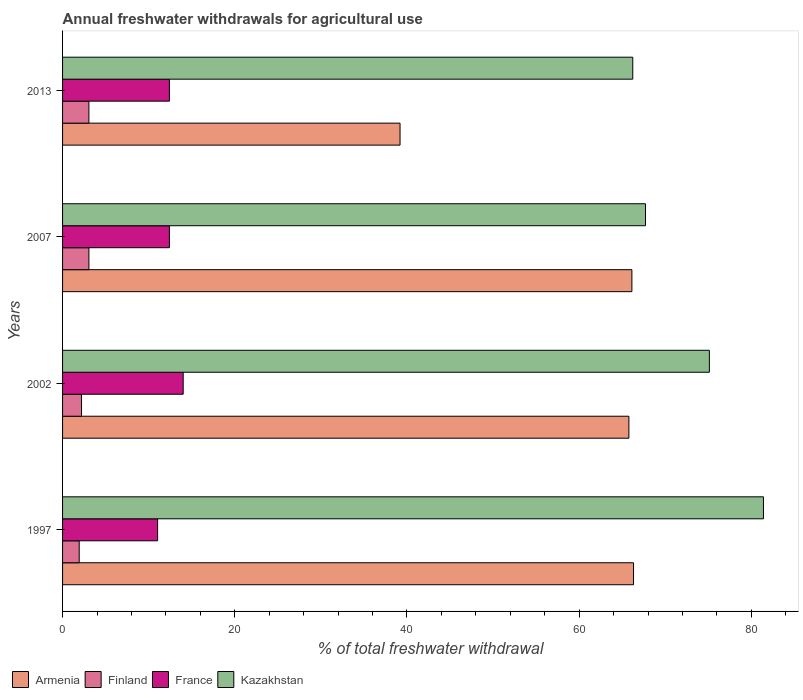How many different coloured bars are there?
Your answer should be very brief. 4. How many groups of bars are there?
Offer a terse response. 4. Are the number of bars per tick equal to the number of legend labels?
Provide a succinct answer. Yes. How many bars are there on the 3rd tick from the top?
Provide a succinct answer. 4. How many bars are there on the 1st tick from the bottom?
Provide a short and direct response. 4. What is the label of the 4th group of bars from the top?
Offer a terse response. 1997. What is the total annual withdrawals from freshwater in Finland in 2007?
Your answer should be compact. 3.06. Across all years, what is the maximum total annual withdrawals from freshwater in France?
Make the answer very short. 14.01. Across all years, what is the minimum total annual withdrawals from freshwater in France?
Provide a succinct answer. 11.04. In which year was the total annual withdrawals from freshwater in Finland maximum?
Offer a very short reply. 2007. What is the total total annual withdrawals from freshwater in Armenia in the graph?
Keep it short and to the point. 237.43. What is the difference between the total annual withdrawals from freshwater in Kazakhstan in 1997 and that in 2007?
Your answer should be compact. 13.7. What is the difference between the total annual withdrawals from freshwater in Armenia in 1997 and the total annual withdrawals from freshwater in France in 2002?
Your answer should be compact. 52.31. What is the average total annual withdrawals from freshwater in Kazakhstan per year?
Make the answer very short. 72.62. In the year 2013, what is the difference between the total annual withdrawals from freshwater in Armenia and total annual withdrawals from freshwater in France?
Your response must be concise. 26.79. What is the ratio of the total annual withdrawals from freshwater in Finland in 2002 to that in 2007?
Offer a very short reply. 0.72. Is the total annual withdrawals from freshwater in Armenia in 2002 less than that in 2013?
Your answer should be compact. No. What is the difference between the highest and the second highest total annual withdrawals from freshwater in Kazakhstan?
Provide a short and direct response. 6.28. What is the difference between the highest and the lowest total annual withdrawals from freshwater in Kazakhstan?
Your response must be concise. 15.18. Is the sum of the total annual withdrawals from freshwater in Armenia in 2002 and 2013 greater than the maximum total annual withdrawals from freshwater in France across all years?
Your response must be concise. Yes. Is it the case that in every year, the sum of the total annual withdrawals from freshwater in Kazakhstan and total annual withdrawals from freshwater in Finland is greater than the sum of total annual withdrawals from freshwater in Armenia and total annual withdrawals from freshwater in France?
Offer a very short reply. Yes. What does the 3rd bar from the top in 2013 represents?
Make the answer very short. Finland. What does the 4th bar from the bottom in 2002 represents?
Your answer should be very brief. Kazakhstan. Is it the case that in every year, the sum of the total annual withdrawals from freshwater in France and total annual withdrawals from freshwater in Finland is greater than the total annual withdrawals from freshwater in Kazakhstan?
Your answer should be compact. No. Are all the bars in the graph horizontal?
Provide a short and direct response. Yes. How many years are there in the graph?
Your answer should be compact. 4. Does the graph contain any zero values?
Ensure brevity in your answer.  No. What is the title of the graph?
Your answer should be compact. Annual freshwater withdrawals for agricultural use. What is the label or title of the X-axis?
Offer a very short reply. % of total freshwater withdrawal. What is the % of total freshwater withdrawal of Armenia in 1997?
Ensure brevity in your answer.  66.32. What is the % of total freshwater withdrawal in Finland in 1997?
Give a very brief answer. 1.93. What is the % of total freshwater withdrawal in France in 1997?
Make the answer very short. 11.04. What is the % of total freshwater withdrawal in Kazakhstan in 1997?
Your answer should be compact. 81.41. What is the % of total freshwater withdrawal in Armenia in 2002?
Your answer should be very brief. 65.78. What is the % of total freshwater withdrawal in Finland in 2002?
Make the answer very short. 2.2. What is the % of total freshwater withdrawal in France in 2002?
Your answer should be very brief. 14.01. What is the % of total freshwater withdrawal in Kazakhstan in 2002?
Keep it short and to the point. 75.13. What is the % of total freshwater withdrawal of Armenia in 2007?
Offer a very short reply. 66.13. What is the % of total freshwater withdrawal of Finland in 2007?
Give a very brief answer. 3.06. What is the % of total freshwater withdrawal of France in 2007?
Offer a very short reply. 12.41. What is the % of total freshwater withdrawal of Kazakhstan in 2007?
Give a very brief answer. 67.71. What is the % of total freshwater withdrawal in Armenia in 2013?
Your answer should be very brief. 39.2. What is the % of total freshwater withdrawal of Finland in 2013?
Keep it short and to the point. 3.06. What is the % of total freshwater withdrawal in France in 2013?
Give a very brief answer. 12.41. What is the % of total freshwater withdrawal in Kazakhstan in 2013?
Your answer should be very brief. 66.23. Across all years, what is the maximum % of total freshwater withdrawal of Armenia?
Give a very brief answer. 66.32. Across all years, what is the maximum % of total freshwater withdrawal in Finland?
Your answer should be very brief. 3.06. Across all years, what is the maximum % of total freshwater withdrawal in France?
Provide a succinct answer. 14.01. Across all years, what is the maximum % of total freshwater withdrawal in Kazakhstan?
Your answer should be compact. 81.41. Across all years, what is the minimum % of total freshwater withdrawal of Armenia?
Keep it short and to the point. 39.2. Across all years, what is the minimum % of total freshwater withdrawal of Finland?
Your answer should be compact. 1.93. Across all years, what is the minimum % of total freshwater withdrawal of France?
Make the answer very short. 11.04. Across all years, what is the minimum % of total freshwater withdrawal in Kazakhstan?
Provide a succinct answer. 66.23. What is the total % of total freshwater withdrawal in Armenia in the graph?
Your answer should be very brief. 237.43. What is the total % of total freshwater withdrawal of Finland in the graph?
Ensure brevity in your answer.  10.26. What is the total % of total freshwater withdrawal of France in the graph?
Make the answer very short. 49.87. What is the total % of total freshwater withdrawal of Kazakhstan in the graph?
Your answer should be very brief. 290.48. What is the difference between the % of total freshwater withdrawal in Armenia in 1997 and that in 2002?
Make the answer very short. 0.54. What is the difference between the % of total freshwater withdrawal in Finland in 1997 and that in 2002?
Your response must be concise. -0.27. What is the difference between the % of total freshwater withdrawal of France in 1997 and that in 2002?
Keep it short and to the point. -2.97. What is the difference between the % of total freshwater withdrawal of Kazakhstan in 1997 and that in 2002?
Offer a very short reply. 6.28. What is the difference between the % of total freshwater withdrawal in Armenia in 1997 and that in 2007?
Offer a terse response. 0.19. What is the difference between the % of total freshwater withdrawal of Finland in 1997 and that in 2007?
Provide a succinct answer. -1.13. What is the difference between the % of total freshwater withdrawal of France in 1997 and that in 2007?
Ensure brevity in your answer.  -1.37. What is the difference between the % of total freshwater withdrawal in Armenia in 1997 and that in 2013?
Provide a short and direct response. 27.12. What is the difference between the % of total freshwater withdrawal in Finland in 1997 and that in 2013?
Keep it short and to the point. -1.13. What is the difference between the % of total freshwater withdrawal in France in 1997 and that in 2013?
Provide a short and direct response. -1.37. What is the difference between the % of total freshwater withdrawal of Kazakhstan in 1997 and that in 2013?
Give a very brief answer. 15.18. What is the difference between the % of total freshwater withdrawal in Armenia in 2002 and that in 2007?
Make the answer very short. -0.35. What is the difference between the % of total freshwater withdrawal of Finland in 2002 and that in 2007?
Offer a very short reply. -0.86. What is the difference between the % of total freshwater withdrawal in France in 2002 and that in 2007?
Offer a terse response. 1.6. What is the difference between the % of total freshwater withdrawal in Kazakhstan in 2002 and that in 2007?
Provide a short and direct response. 7.42. What is the difference between the % of total freshwater withdrawal of Armenia in 2002 and that in 2013?
Provide a short and direct response. 26.58. What is the difference between the % of total freshwater withdrawal in Finland in 2002 and that in 2013?
Make the answer very short. -0.86. What is the difference between the % of total freshwater withdrawal in Kazakhstan in 2002 and that in 2013?
Provide a short and direct response. 8.9. What is the difference between the % of total freshwater withdrawal of Armenia in 2007 and that in 2013?
Make the answer very short. 26.93. What is the difference between the % of total freshwater withdrawal of Finland in 2007 and that in 2013?
Your answer should be very brief. 0. What is the difference between the % of total freshwater withdrawal of Kazakhstan in 2007 and that in 2013?
Offer a terse response. 1.48. What is the difference between the % of total freshwater withdrawal in Armenia in 1997 and the % of total freshwater withdrawal in Finland in 2002?
Provide a succinct answer. 64.12. What is the difference between the % of total freshwater withdrawal of Armenia in 1997 and the % of total freshwater withdrawal of France in 2002?
Your answer should be compact. 52.31. What is the difference between the % of total freshwater withdrawal of Armenia in 1997 and the % of total freshwater withdrawal of Kazakhstan in 2002?
Offer a very short reply. -8.81. What is the difference between the % of total freshwater withdrawal in Finland in 1997 and the % of total freshwater withdrawal in France in 2002?
Ensure brevity in your answer.  -12.08. What is the difference between the % of total freshwater withdrawal of Finland in 1997 and the % of total freshwater withdrawal of Kazakhstan in 2002?
Keep it short and to the point. -73.2. What is the difference between the % of total freshwater withdrawal of France in 1997 and the % of total freshwater withdrawal of Kazakhstan in 2002?
Offer a very short reply. -64.09. What is the difference between the % of total freshwater withdrawal of Armenia in 1997 and the % of total freshwater withdrawal of Finland in 2007?
Offer a very short reply. 63.26. What is the difference between the % of total freshwater withdrawal in Armenia in 1997 and the % of total freshwater withdrawal in France in 2007?
Your answer should be compact. 53.91. What is the difference between the % of total freshwater withdrawal in Armenia in 1997 and the % of total freshwater withdrawal in Kazakhstan in 2007?
Your answer should be very brief. -1.39. What is the difference between the % of total freshwater withdrawal in Finland in 1997 and the % of total freshwater withdrawal in France in 2007?
Offer a very short reply. -10.48. What is the difference between the % of total freshwater withdrawal of Finland in 1997 and the % of total freshwater withdrawal of Kazakhstan in 2007?
Offer a terse response. -65.78. What is the difference between the % of total freshwater withdrawal in France in 1997 and the % of total freshwater withdrawal in Kazakhstan in 2007?
Ensure brevity in your answer.  -56.67. What is the difference between the % of total freshwater withdrawal of Armenia in 1997 and the % of total freshwater withdrawal of Finland in 2013?
Your answer should be compact. 63.26. What is the difference between the % of total freshwater withdrawal in Armenia in 1997 and the % of total freshwater withdrawal in France in 2013?
Provide a succinct answer. 53.91. What is the difference between the % of total freshwater withdrawal of Armenia in 1997 and the % of total freshwater withdrawal of Kazakhstan in 2013?
Offer a terse response. 0.09. What is the difference between the % of total freshwater withdrawal in Finland in 1997 and the % of total freshwater withdrawal in France in 2013?
Provide a succinct answer. -10.48. What is the difference between the % of total freshwater withdrawal of Finland in 1997 and the % of total freshwater withdrawal of Kazakhstan in 2013?
Offer a terse response. -64.3. What is the difference between the % of total freshwater withdrawal in France in 1997 and the % of total freshwater withdrawal in Kazakhstan in 2013?
Keep it short and to the point. -55.19. What is the difference between the % of total freshwater withdrawal of Armenia in 2002 and the % of total freshwater withdrawal of Finland in 2007?
Your answer should be very brief. 62.72. What is the difference between the % of total freshwater withdrawal in Armenia in 2002 and the % of total freshwater withdrawal in France in 2007?
Keep it short and to the point. 53.37. What is the difference between the % of total freshwater withdrawal of Armenia in 2002 and the % of total freshwater withdrawal of Kazakhstan in 2007?
Make the answer very short. -1.93. What is the difference between the % of total freshwater withdrawal in Finland in 2002 and the % of total freshwater withdrawal in France in 2007?
Provide a short and direct response. -10.21. What is the difference between the % of total freshwater withdrawal in Finland in 2002 and the % of total freshwater withdrawal in Kazakhstan in 2007?
Provide a succinct answer. -65.51. What is the difference between the % of total freshwater withdrawal in France in 2002 and the % of total freshwater withdrawal in Kazakhstan in 2007?
Offer a terse response. -53.7. What is the difference between the % of total freshwater withdrawal in Armenia in 2002 and the % of total freshwater withdrawal in Finland in 2013?
Provide a short and direct response. 62.72. What is the difference between the % of total freshwater withdrawal in Armenia in 2002 and the % of total freshwater withdrawal in France in 2013?
Give a very brief answer. 53.37. What is the difference between the % of total freshwater withdrawal in Armenia in 2002 and the % of total freshwater withdrawal in Kazakhstan in 2013?
Give a very brief answer. -0.45. What is the difference between the % of total freshwater withdrawal of Finland in 2002 and the % of total freshwater withdrawal of France in 2013?
Give a very brief answer. -10.21. What is the difference between the % of total freshwater withdrawal in Finland in 2002 and the % of total freshwater withdrawal in Kazakhstan in 2013?
Ensure brevity in your answer.  -64.03. What is the difference between the % of total freshwater withdrawal in France in 2002 and the % of total freshwater withdrawal in Kazakhstan in 2013?
Offer a very short reply. -52.22. What is the difference between the % of total freshwater withdrawal in Armenia in 2007 and the % of total freshwater withdrawal in Finland in 2013?
Provide a short and direct response. 63.07. What is the difference between the % of total freshwater withdrawal of Armenia in 2007 and the % of total freshwater withdrawal of France in 2013?
Make the answer very short. 53.72. What is the difference between the % of total freshwater withdrawal in Armenia in 2007 and the % of total freshwater withdrawal in Kazakhstan in 2013?
Provide a short and direct response. -0.1. What is the difference between the % of total freshwater withdrawal of Finland in 2007 and the % of total freshwater withdrawal of France in 2013?
Provide a succinct answer. -9.35. What is the difference between the % of total freshwater withdrawal of Finland in 2007 and the % of total freshwater withdrawal of Kazakhstan in 2013?
Your response must be concise. -63.17. What is the difference between the % of total freshwater withdrawal in France in 2007 and the % of total freshwater withdrawal in Kazakhstan in 2013?
Your answer should be very brief. -53.82. What is the average % of total freshwater withdrawal in Armenia per year?
Your answer should be very brief. 59.36. What is the average % of total freshwater withdrawal in Finland per year?
Your response must be concise. 2.56. What is the average % of total freshwater withdrawal in France per year?
Keep it short and to the point. 12.47. What is the average % of total freshwater withdrawal in Kazakhstan per year?
Ensure brevity in your answer.  72.62. In the year 1997, what is the difference between the % of total freshwater withdrawal of Armenia and % of total freshwater withdrawal of Finland?
Your answer should be compact. 64.39. In the year 1997, what is the difference between the % of total freshwater withdrawal of Armenia and % of total freshwater withdrawal of France?
Your answer should be compact. 55.28. In the year 1997, what is the difference between the % of total freshwater withdrawal in Armenia and % of total freshwater withdrawal in Kazakhstan?
Keep it short and to the point. -15.09. In the year 1997, what is the difference between the % of total freshwater withdrawal in Finland and % of total freshwater withdrawal in France?
Your answer should be compact. -9.11. In the year 1997, what is the difference between the % of total freshwater withdrawal in Finland and % of total freshwater withdrawal in Kazakhstan?
Offer a very short reply. -79.48. In the year 1997, what is the difference between the % of total freshwater withdrawal of France and % of total freshwater withdrawal of Kazakhstan?
Make the answer very short. -70.37. In the year 2002, what is the difference between the % of total freshwater withdrawal of Armenia and % of total freshwater withdrawal of Finland?
Offer a terse response. 63.58. In the year 2002, what is the difference between the % of total freshwater withdrawal of Armenia and % of total freshwater withdrawal of France?
Make the answer very short. 51.77. In the year 2002, what is the difference between the % of total freshwater withdrawal of Armenia and % of total freshwater withdrawal of Kazakhstan?
Make the answer very short. -9.35. In the year 2002, what is the difference between the % of total freshwater withdrawal in Finland and % of total freshwater withdrawal in France?
Offer a very short reply. -11.81. In the year 2002, what is the difference between the % of total freshwater withdrawal in Finland and % of total freshwater withdrawal in Kazakhstan?
Your answer should be very brief. -72.93. In the year 2002, what is the difference between the % of total freshwater withdrawal in France and % of total freshwater withdrawal in Kazakhstan?
Your response must be concise. -61.12. In the year 2007, what is the difference between the % of total freshwater withdrawal of Armenia and % of total freshwater withdrawal of Finland?
Offer a terse response. 63.07. In the year 2007, what is the difference between the % of total freshwater withdrawal in Armenia and % of total freshwater withdrawal in France?
Your response must be concise. 53.72. In the year 2007, what is the difference between the % of total freshwater withdrawal in Armenia and % of total freshwater withdrawal in Kazakhstan?
Your response must be concise. -1.58. In the year 2007, what is the difference between the % of total freshwater withdrawal of Finland and % of total freshwater withdrawal of France?
Your answer should be compact. -9.35. In the year 2007, what is the difference between the % of total freshwater withdrawal of Finland and % of total freshwater withdrawal of Kazakhstan?
Your response must be concise. -64.65. In the year 2007, what is the difference between the % of total freshwater withdrawal of France and % of total freshwater withdrawal of Kazakhstan?
Your answer should be very brief. -55.3. In the year 2013, what is the difference between the % of total freshwater withdrawal in Armenia and % of total freshwater withdrawal in Finland?
Ensure brevity in your answer.  36.14. In the year 2013, what is the difference between the % of total freshwater withdrawal of Armenia and % of total freshwater withdrawal of France?
Your answer should be very brief. 26.79. In the year 2013, what is the difference between the % of total freshwater withdrawal of Armenia and % of total freshwater withdrawal of Kazakhstan?
Provide a succinct answer. -27.03. In the year 2013, what is the difference between the % of total freshwater withdrawal in Finland and % of total freshwater withdrawal in France?
Keep it short and to the point. -9.35. In the year 2013, what is the difference between the % of total freshwater withdrawal of Finland and % of total freshwater withdrawal of Kazakhstan?
Offer a very short reply. -63.17. In the year 2013, what is the difference between the % of total freshwater withdrawal of France and % of total freshwater withdrawal of Kazakhstan?
Provide a succinct answer. -53.82. What is the ratio of the % of total freshwater withdrawal in Armenia in 1997 to that in 2002?
Provide a succinct answer. 1.01. What is the ratio of the % of total freshwater withdrawal in Finland in 1997 to that in 2002?
Your answer should be compact. 0.88. What is the ratio of the % of total freshwater withdrawal in France in 1997 to that in 2002?
Your response must be concise. 0.79. What is the ratio of the % of total freshwater withdrawal of Kazakhstan in 1997 to that in 2002?
Offer a very short reply. 1.08. What is the ratio of the % of total freshwater withdrawal in Armenia in 1997 to that in 2007?
Keep it short and to the point. 1. What is the ratio of the % of total freshwater withdrawal in Finland in 1997 to that in 2007?
Provide a short and direct response. 0.63. What is the ratio of the % of total freshwater withdrawal in France in 1997 to that in 2007?
Offer a very short reply. 0.89. What is the ratio of the % of total freshwater withdrawal in Kazakhstan in 1997 to that in 2007?
Keep it short and to the point. 1.2. What is the ratio of the % of total freshwater withdrawal in Armenia in 1997 to that in 2013?
Your response must be concise. 1.69. What is the ratio of the % of total freshwater withdrawal of Finland in 1997 to that in 2013?
Offer a terse response. 0.63. What is the ratio of the % of total freshwater withdrawal of France in 1997 to that in 2013?
Give a very brief answer. 0.89. What is the ratio of the % of total freshwater withdrawal in Kazakhstan in 1997 to that in 2013?
Offer a terse response. 1.23. What is the ratio of the % of total freshwater withdrawal in Finland in 2002 to that in 2007?
Your answer should be compact. 0.72. What is the ratio of the % of total freshwater withdrawal of France in 2002 to that in 2007?
Your response must be concise. 1.13. What is the ratio of the % of total freshwater withdrawal of Kazakhstan in 2002 to that in 2007?
Your answer should be very brief. 1.11. What is the ratio of the % of total freshwater withdrawal in Armenia in 2002 to that in 2013?
Your answer should be very brief. 1.68. What is the ratio of the % of total freshwater withdrawal of Finland in 2002 to that in 2013?
Your answer should be compact. 0.72. What is the ratio of the % of total freshwater withdrawal in France in 2002 to that in 2013?
Provide a short and direct response. 1.13. What is the ratio of the % of total freshwater withdrawal in Kazakhstan in 2002 to that in 2013?
Your answer should be very brief. 1.13. What is the ratio of the % of total freshwater withdrawal of Armenia in 2007 to that in 2013?
Offer a very short reply. 1.69. What is the ratio of the % of total freshwater withdrawal of Finland in 2007 to that in 2013?
Make the answer very short. 1. What is the ratio of the % of total freshwater withdrawal of Kazakhstan in 2007 to that in 2013?
Offer a very short reply. 1.02. What is the difference between the highest and the second highest % of total freshwater withdrawal of Armenia?
Provide a succinct answer. 0.19. What is the difference between the highest and the second highest % of total freshwater withdrawal in Finland?
Your answer should be compact. 0. What is the difference between the highest and the second highest % of total freshwater withdrawal of Kazakhstan?
Your answer should be compact. 6.28. What is the difference between the highest and the lowest % of total freshwater withdrawal of Armenia?
Offer a very short reply. 27.12. What is the difference between the highest and the lowest % of total freshwater withdrawal in Finland?
Give a very brief answer. 1.13. What is the difference between the highest and the lowest % of total freshwater withdrawal of France?
Keep it short and to the point. 2.97. What is the difference between the highest and the lowest % of total freshwater withdrawal in Kazakhstan?
Offer a terse response. 15.18. 